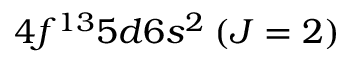Convert formula to latex. <formula><loc_0><loc_0><loc_500><loc_500>4 f ^ { 1 3 } 5 d 6 s ^ { 2 } \, ( J = 2 )</formula> 